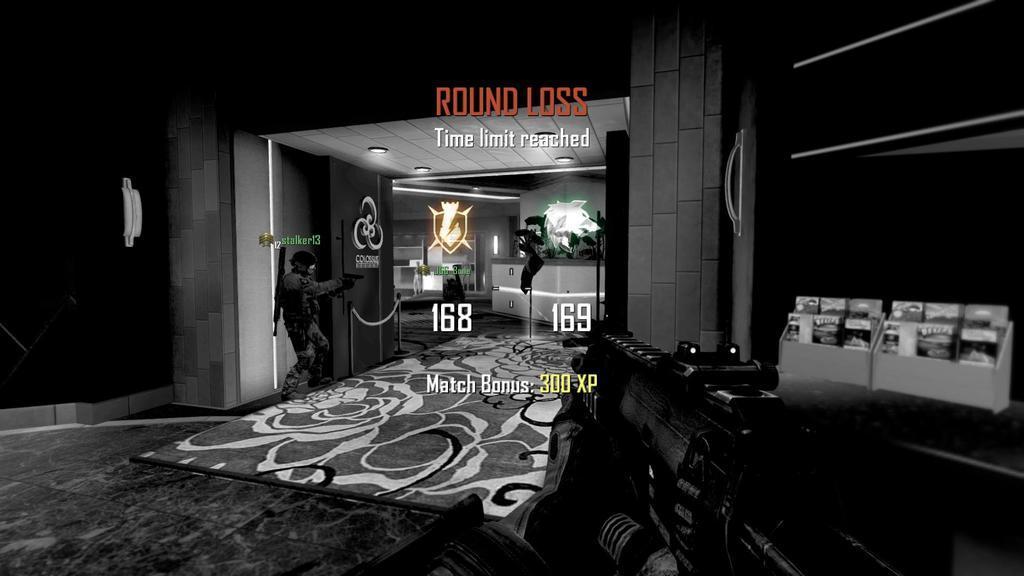How would you summarize this image in a sentence or two? This is an animated image. We can see a man is holding a gun. Behind the person there are with a rope and there are some other objects. At the bottom of the image, there is a gun. On the image, there are logos, words and numbers. 